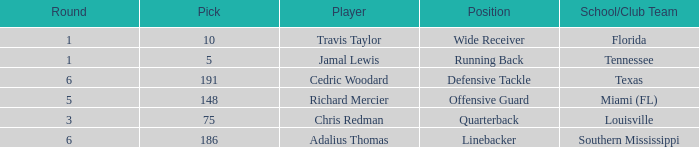What's the highest round that louisville drafted into when their pick was over 75? None. 